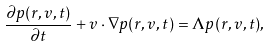Convert formula to latex. <formula><loc_0><loc_0><loc_500><loc_500>\frac { \partial p ( { r } , { v } , t ) } { \partial t } + { v } \cdot \nabla p ( { r } , { v } , t ) = \Lambda p ( { r } , { v } , t ) ,</formula> 